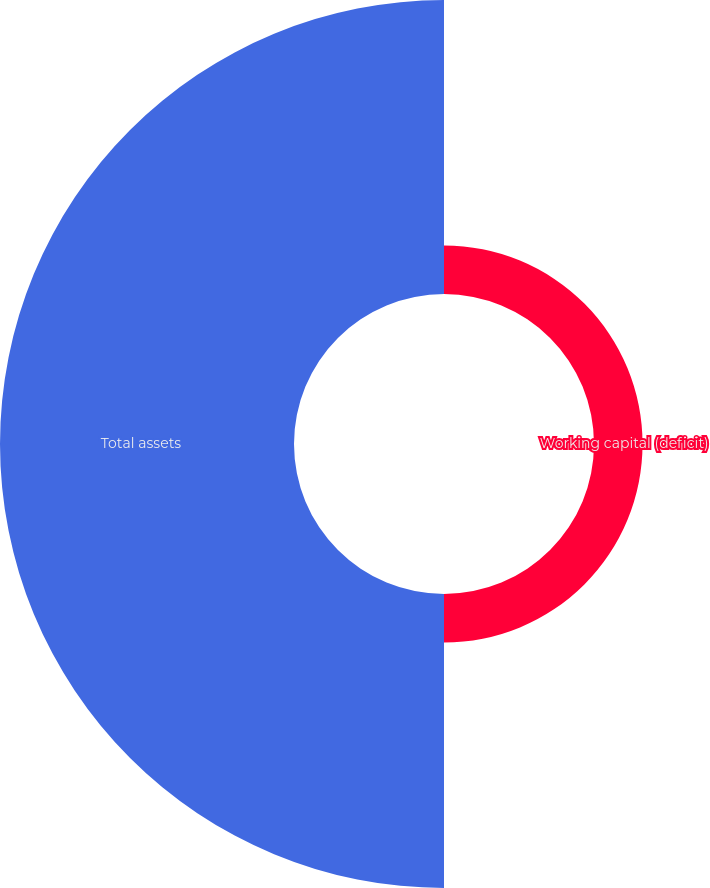Convert chart to OTSL. <chart><loc_0><loc_0><loc_500><loc_500><pie_chart><fcel>Working capital (deficit)<fcel>Total assets<nl><fcel>14.17%<fcel>85.83%<nl></chart> 